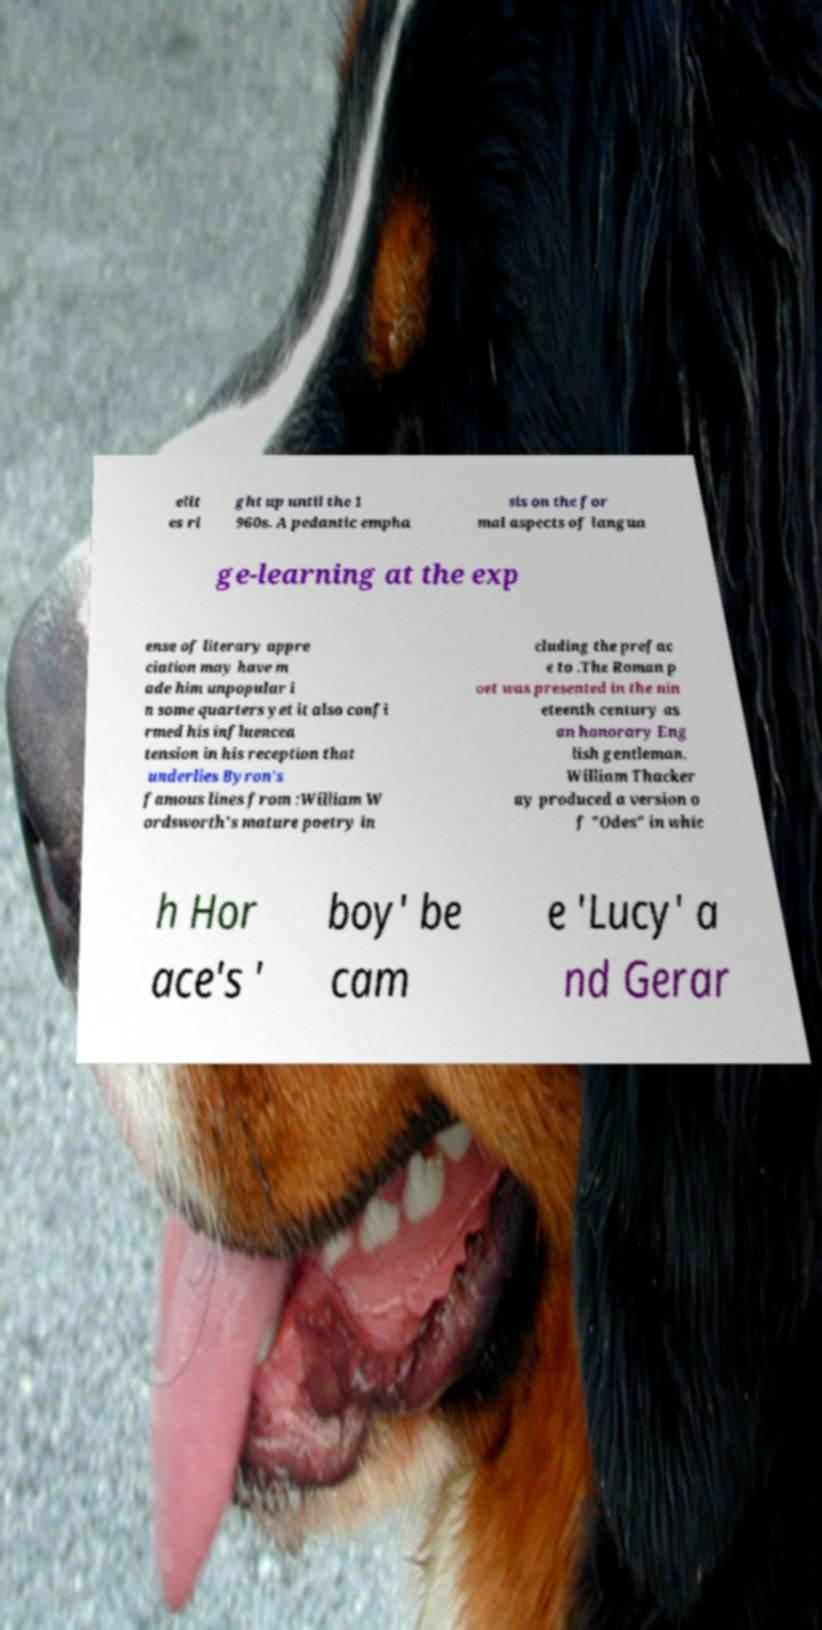I need the written content from this picture converted into text. Can you do that? elit es ri ght up until the 1 960s. A pedantic empha sis on the for mal aspects of langua ge-learning at the exp ense of literary appre ciation may have m ade him unpopular i n some quarters yet it also confi rmed his influencea tension in his reception that underlies Byron's famous lines from :William W ordsworth's mature poetry in cluding the prefac e to .The Roman p oet was presented in the nin eteenth century as an honorary Eng lish gentleman. William Thacker ay produced a version o f "Odes" in whic h Hor ace's ' boy' be cam e 'Lucy' a nd Gerar 